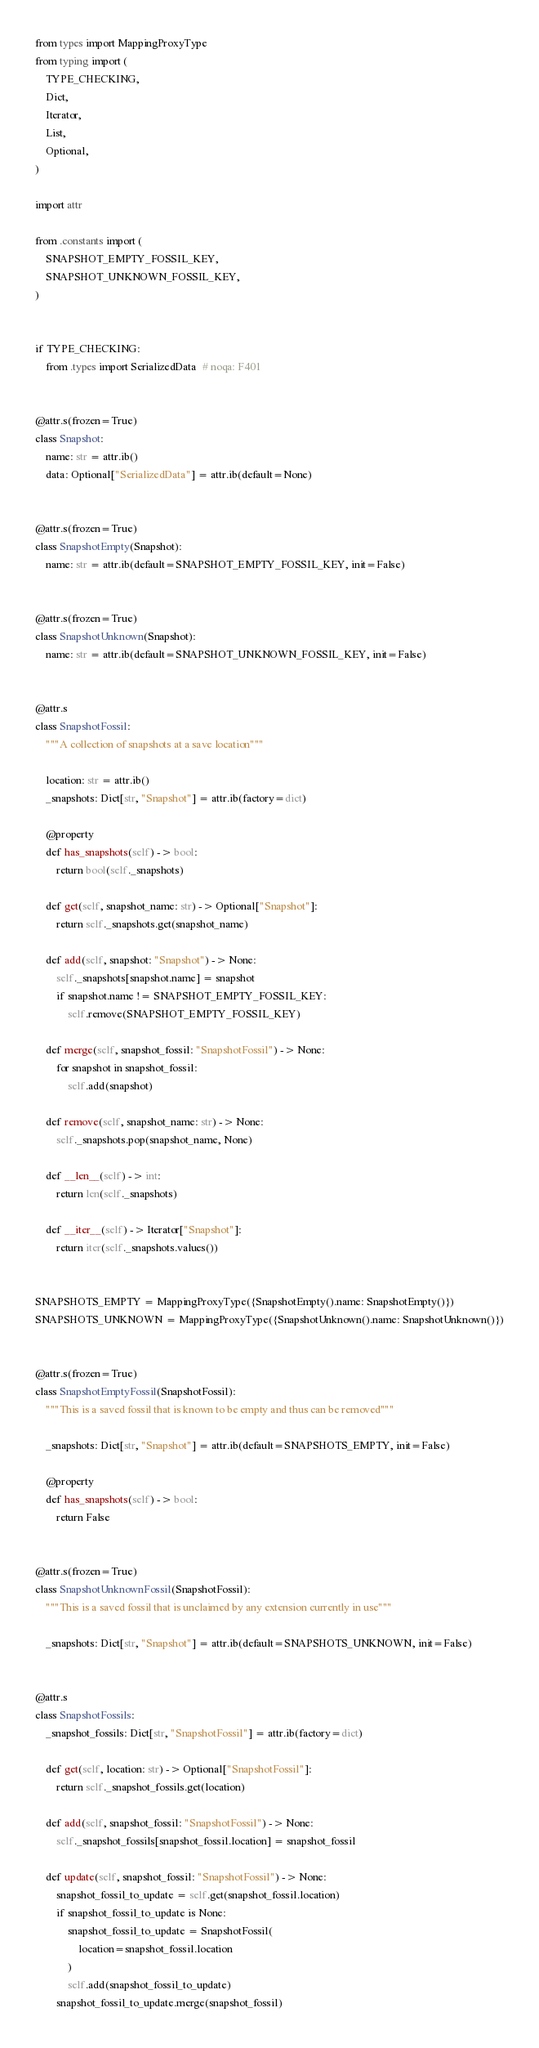<code> <loc_0><loc_0><loc_500><loc_500><_Python_>from types import MappingProxyType
from typing import (
    TYPE_CHECKING,
    Dict,
    Iterator,
    List,
    Optional,
)

import attr

from .constants import (
    SNAPSHOT_EMPTY_FOSSIL_KEY,
    SNAPSHOT_UNKNOWN_FOSSIL_KEY,
)


if TYPE_CHECKING:
    from .types import SerializedData  # noqa: F401


@attr.s(frozen=True)
class Snapshot:
    name: str = attr.ib()
    data: Optional["SerializedData"] = attr.ib(default=None)


@attr.s(frozen=True)
class SnapshotEmpty(Snapshot):
    name: str = attr.ib(default=SNAPSHOT_EMPTY_FOSSIL_KEY, init=False)


@attr.s(frozen=True)
class SnapshotUnknown(Snapshot):
    name: str = attr.ib(default=SNAPSHOT_UNKNOWN_FOSSIL_KEY, init=False)


@attr.s
class SnapshotFossil:
    """A collection of snapshots at a save location"""

    location: str = attr.ib()
    _snapshots: Dict[str, "Snapshot"] = attr.ib(factory=dict)

    @property
    def has_snapshots(self) -> bool:
        return bool(self._snapshots)

    def get(self, snapshot_name: str) -> Optional["Snapshot"]:
        return self._snapshots.get(snapshot_name)

    def add(self, snapshot: "Snapshot") -> None:
        self._snapshots[snapshot.name] = snapshot
        if snapshot.name != SNAPSHOT_EMPTY_FOSSIL_KEY:
            self.remove(SNAPSHOT_EMPTY_FOSSIL_KEY)

    def merge(self, snapshot_fossil: "SnapshotFossil") -> None:
        for snapshot in snapshot_fossil:
            self.add(snapshot)

    def remove(self, snapshot_name: str) -> None:
        self._snapshots.pop(snapshot_name, None)

    def __len__(self) -> int:
        return len(self._snapshots)

    def __iter__(self) -> Iterator["Snapshot"]:
        return iter(self._snapshots.values())


SNAPSHOTS_EMPTY = MappingProxyType({SnapshotEmpty().name: SnapshotEmpty()})
SNAPSHOTS_UNKNOWN = MappingProxyType({SnapshotUnknown().name: SnapshotUnknown()})


@attr.s(frozen=True)
class SnapshotEmptyFossil(SnapshotFossil):
    """This is a saved fossil that is known to be empty and thus can be removed"""

    _snapshots: Dict[str, "Snapshot"] = attr.ib(default=SNAPSHOTS_EMPTY, init=False)

    @property
    def has_snapshots(self) -> bool:
        return False


@attr.s(frozen=True)
class SnapshotUnknownFossil(SnapshotFossil):
    """This is a saved fossil that is unclaimed by any extension currently in use"""

    _snapshots: Dict[str, "Snapshot"] = attr.ib(default=SNAPSHOTS_UNKNOWN, init=False)


@attr.s
class SnapshotFossils:
    _snapshot_fossils: Dict[str, "SnapshotFossil"] = attr.ib(factory=dict)

    def get(self, location: str) -> Optional["SnapshotFossil"]:
        return self._snapshot_fossils.get(location)

    def add(self, snapshot_fossil: "SnapshotFossil") -> None:
        self._snapshot_fossils[snapshot_fossil.location] = snapshot_fossil

    def update(self, snapshot_fossil: "SnapshotFossil") -> None:
        snapshot_fossil_to_update = self.get(snapshot_fossil.location)
        if snapshot_fossil_to_update is None:
            snapshot_fossil_to_update = SnapshotFossil(
                location=snapshot_fossil.location
            )
            self.add(snapshot_fossil_to_update)
        snapshot_fossil_to_update.merge(snapshot_fossil)
</code> 